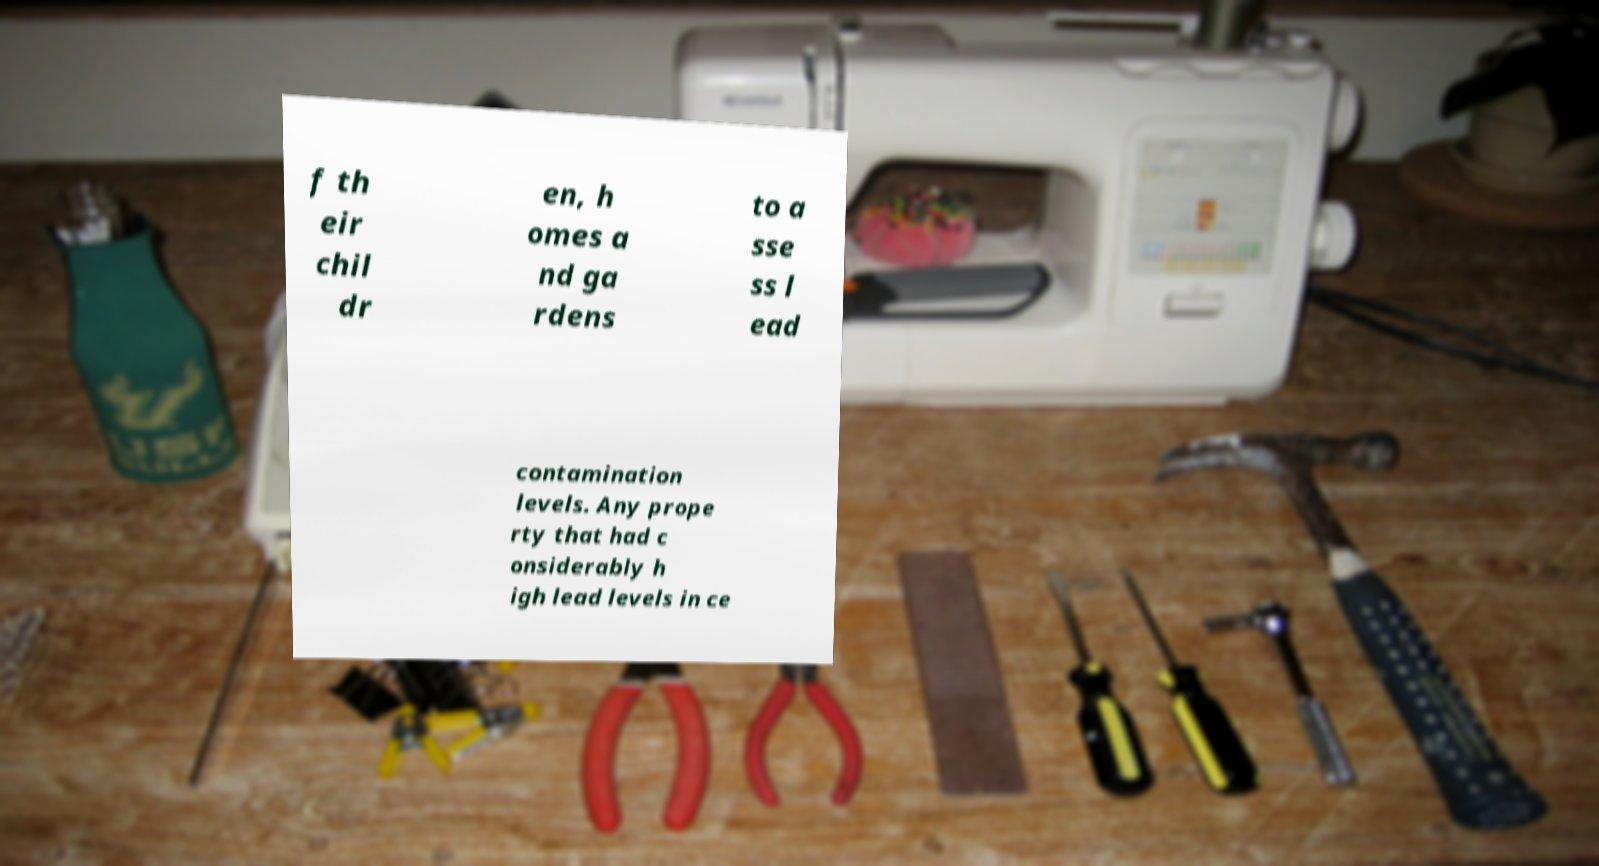Could you assist in decoding the text presented in this image and type it out clearly? f th eir chil dr en, h omes a nd ga rdens to a sse ss l ead contamination levels. Any prope rty that had c onsiderably h igh lead levels in ce 